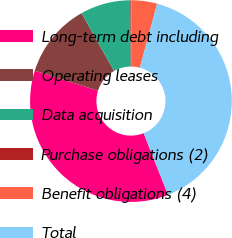<chart> <loc_0><loc_0><loc_500><loc_500><pie_chart><fcel>Long-term debt including<fcel>Operating leases<fcel>Data acquisition<fcel>Purchase obligations (2)<fcel>Benefit obligations (4)<fcel>Total<nl><fcel>35.87%<fcel>11.99%<fcel>8.05%<fcel>0.17%<fcel>4.11%<fcel>39.81%<nl></chart> 